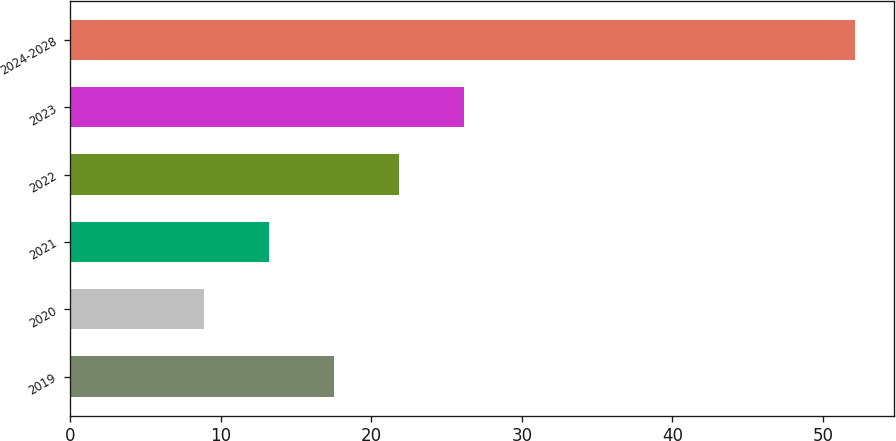Convert chart to OTSL. <chart><loc_0><loc_0><loc_500><loc_500><bar_chart><fcel>2019<fcel>2020<fcel>2021<fcel>2022<fcel>2023<fcel>2024-2028<nl><fcel>17.54<fcel>8.9<fcel>13.22<fcel>21.86<fcel>26.18<fcel>52.1<nl></chart> 